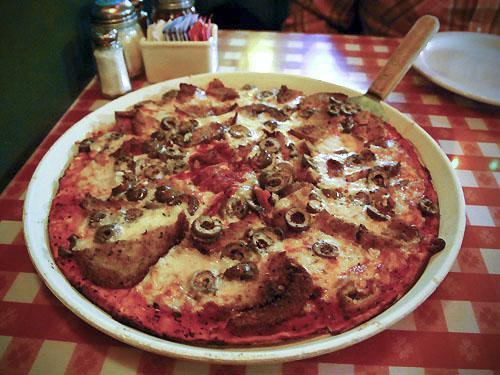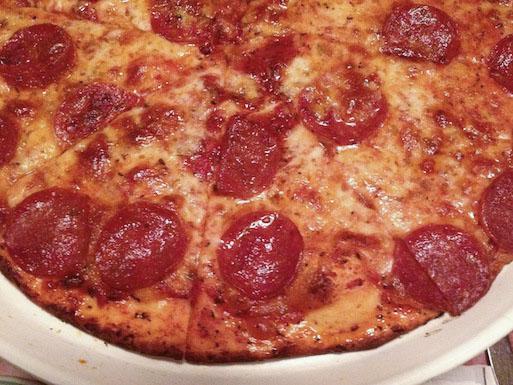The first image is the image on the left, the second image is the image on the right. Considering the images on both sides, is "The pizza in the image on the left is sitting on a red checked table cloth." valid? Answer yes or no. Yes. The first image is the image on the left, the second image is the image on the right. Considering the images on both sides, is "Two pizzas on white plates are baked and ready to eat, one plate sitting on a red checked tablecloth." valid? Answer yes or no. Yes. 